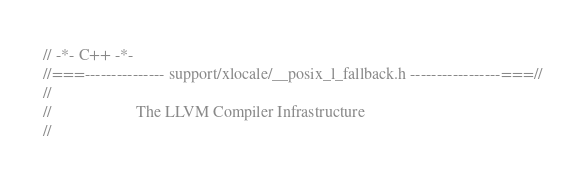Convert code to text. <code><loc_0><loc_0><loc_500><loc_500><_C_>// -*- C++ -*-
//===--------------- support/xlocale/__posix_l_fallback.h -----------------===//
//
//                     The LLVM Compiler Infrastructure
//</code> 